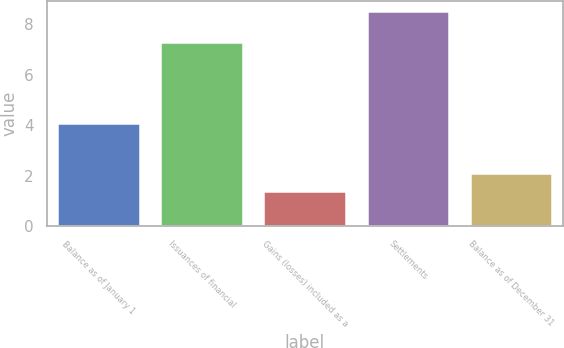<chart> <loc_0><loc_0><loc_500><loc_500><bar_chart><fcel>Balance as of January 1<fcel>Issuances of financial<fcel>Gains (losses) included as a<fcel>Settlements<fcel>Balance as of December 31<nl><fcel>4.1<fcel>7.3<fcel>1.4<fcel>8.5<fcel>2.11<nl></chart> 